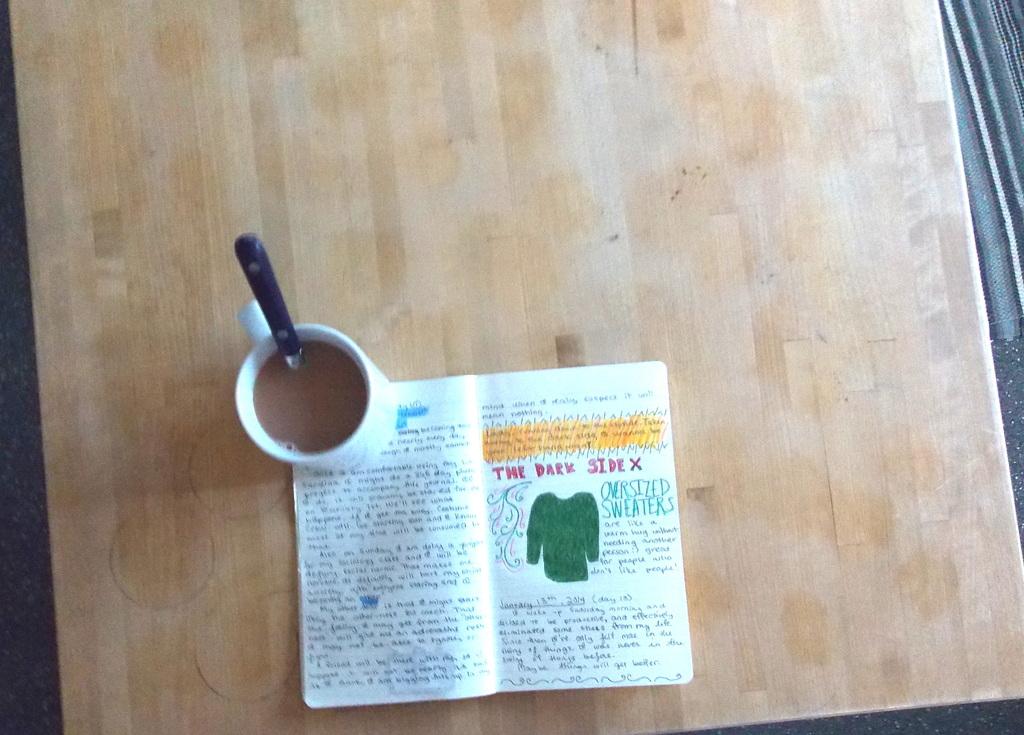What type of sweaters does this person like?
Provide a short and direct response. Oversized. 